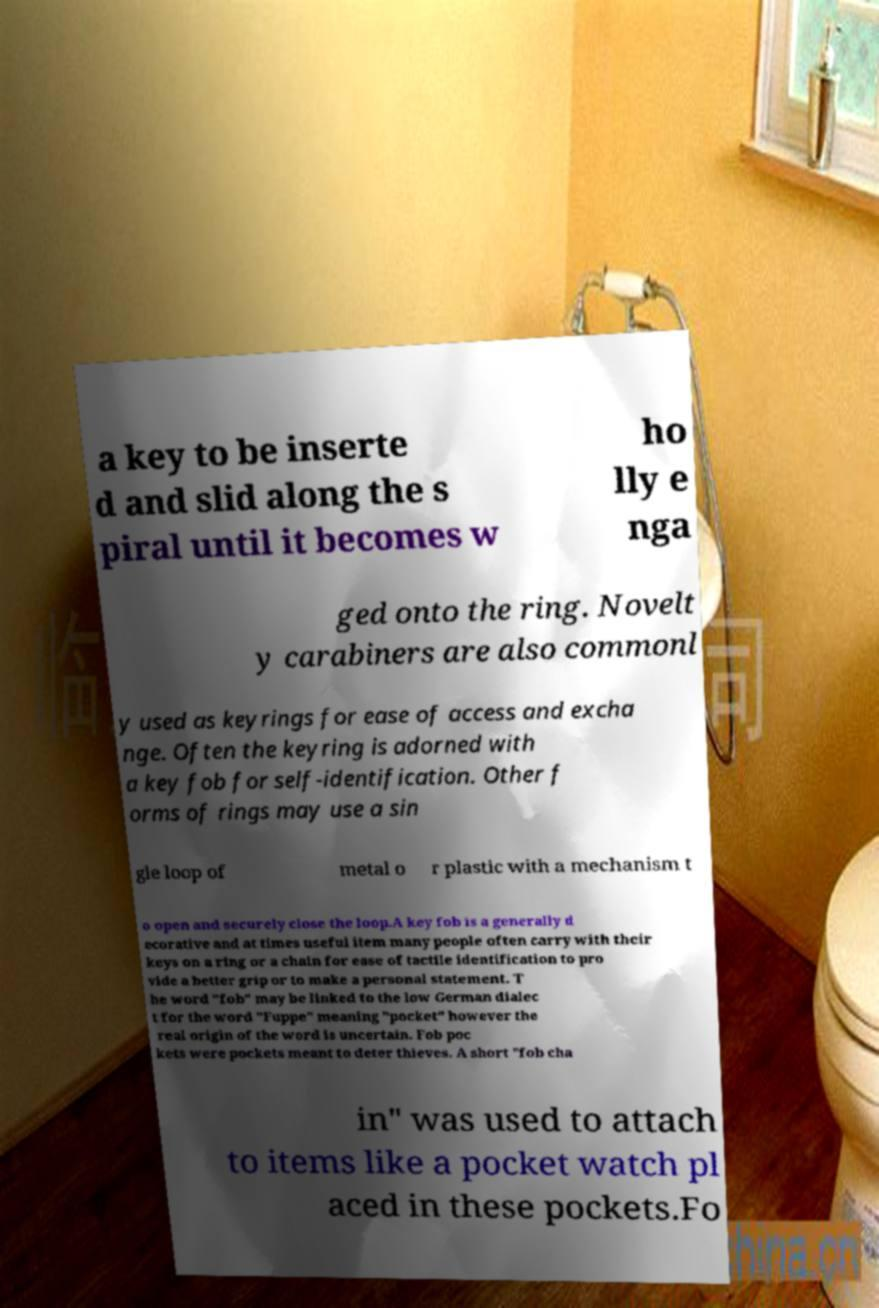Can you accurately transcribe the text from the provided image for me? a key to be inserte d and slid along the s piral until it becomes w ho lly e nga ged onto the ring. Novelt y carabiners are also commonl y used as keyrings for ease of access and excha nge. Often the keyring is adorned with a key fob for self-identification. Other f orms of rings may use a sin gle loop of metal o r plastic with a mechanism t o open and securely close the loop.A key fob is a generally d ecorative and at times useful item many people often carry with their keys on a ring or a chain for ease of tactile identification to pro vide a better grip or to make a personal statement. T he word "fob" may be linked to the low German dialec t for the word "Fuppe" meaning "pocket" however the real origin of the word is uncertain. Fob poc kets were pockets meant to deter thieves. A short "fob cha in" was used to attach to items like a pocket watch pl aced in these pockets.Fo 